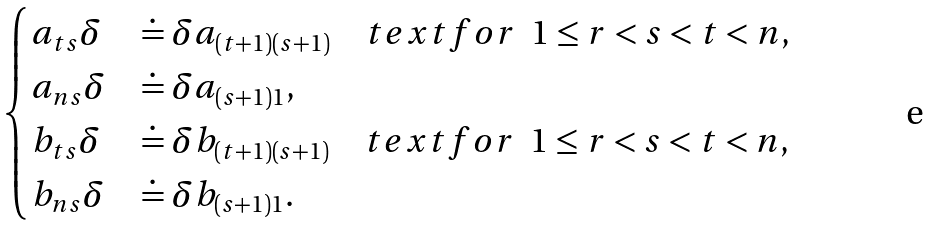<formula> <loc_0><loc_0><loc_500><loc_500>\begin{cases} a _ { t s } \delta & \doteq \delta a _ { ( t + 1 ) ( s + 1 ) } \quad t e x t { f o r } \ \ 1 \leq r < s < t < n , \\ a _ { n s } \delta & \doteq \delta a _ { ( s + 1 ) 1 } , \\ b _ { t s } \delta & \doteq \delta b _ { ( t + 1 ) ( s + 1 ) } \quad t e x t { f o r } \ \ 1 \leq r < s < t < n , \\ b _ { n s } \delta & \doteq \delta b _ { ( s + 1 ) 1 } . \end{cases}</formula> 